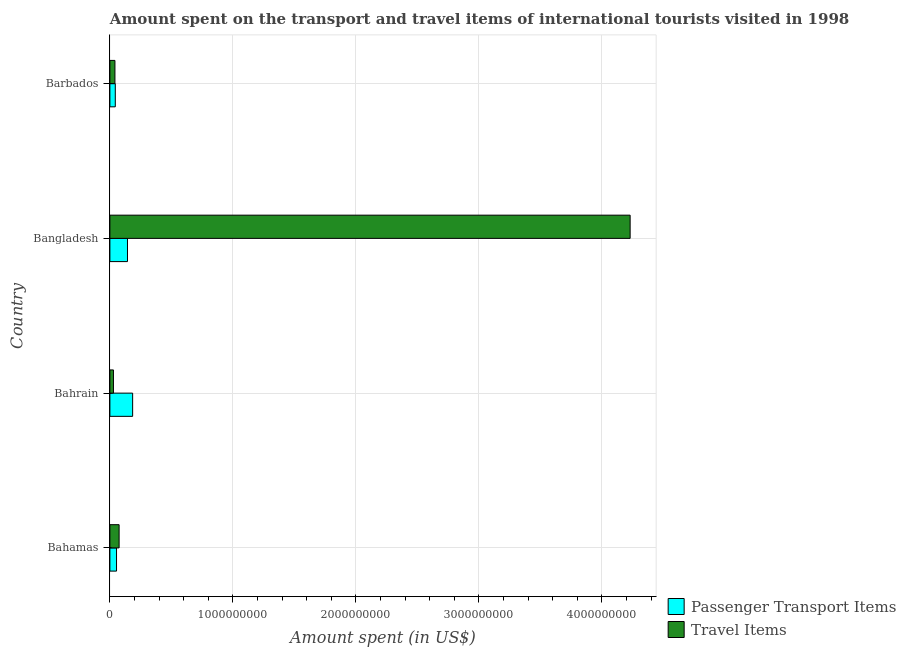Are the number of bars on each tick of the Y-axis equal?
Ensure brevity in your answer.  Yes. How many bars are there on the 1st tick from the top?
Your answer should be compact. 2. How many bars are there on the 1st tick from the bottom?
Ensure brevity in your answer.  2. What is the label of the 2nd group of bars from the top?
Provide a short and direct response. Bangladesh. In how many cases, is the number of bars for a given country not equal to the number of legend labels?
Make the answer very short. 0. What is the amount spent in travel items in Bangladesh?
Give a very brief answer. 4.23e+09. Across all countries, what is the maximum amount spent in travel items?
Make the answer very short. 4.23e+09. Across all countries, what is the minimum amount spent in travel items?
Provide a succinct answer. 2.90e+07. In which country was the amount spent on passenger transport items maximum?
Make the answer very short. Bahrain. In which country was the amount spent in travel items minimum?
Make the answer very short. Bahrain. What is the total amount spent on passenger transport items in the graph?
Give a very brief answer. 4.26e+08. What is the difference between the amount spent in travel items in Bahamas and that in Bangladesh?
Provide a succinct answer. -4.16e+09. What is the difference between the amount spent on passenger transport items in Bahrain and the amount spent in travel items in Barbados?
Provide a short and direct response. 1.44e+08. What is the average amount spent on passenger transport items per country?
Provide a succinct answer. 1.06e+08. What is the difference between the amount spent on passenger transport items and amount spent in travel items in Bahrain?
Offer a very short reply. 1.56e+08. What is the ratio of the amount spent on passenger transport items in Bahrain to that in Barbados?
Provide a short and direct response. 4.21. Is the difference between the amount spent in travel items in Bahrain and Barbados greater than the difference between the amount spent on passenger transport items in Bahrain and Barbados?
Ensure brevity in your answer.  No. What is the difference between the highest and the second highest amount spent in travel items?
Your response must be concise. 4.16e+09. What is the difference between the highest and the lowest amount spent in travel items?
Make the answer very short. 4.20e+09. What does the 2nd bar from the top in Bangladesh represents?
Your answer should be very brief. Passenger Transport Items. What does the 1st bar from the bottom in Bahamas represents?
Give a very brief answer. Passenger Transport Items. How many bars are there?
Provide a succinct answer. 8. How many countries are there in the graph?
Ensure brevity in your answer.  4. What is the difference between two consecutive major ticks on the X-axis?
Keep it short and to the point. 1.00e+09. Are the values on the major ticks of X-axis written in scientific E-notation?
Your answer should be very brief. No. Does the graph contain grids?
Give a very brief answer. Yes. How many legend labels are there?
Offer a very short reply. 2. How are the legend labels stacked?
Provide a short and direct response. Vertical. What is the title of the graph?
Give a very brief answer. Amount spent on the transport and travel items of international tourists visited in 1998. What is the label or title of the X-axis?
Your answer should be very brief. Amount spent (in US$). What is the label or title of the Y-axis?
Your answer should be very brief. Country. What is the Amount spent (in US$) of Passenger Transport Items in Bahamas?
Keep it short and to the point. 5.40e+07. What is the Amount spent (in US$) of Travel Items in Bahamas?
Provide a succinct answer. 7.50e+07. What is the Amount spent (in US$) of Passenger Transport Items in Bahrain?
Your response must be concise. 1.85e+08. What is the Amount spent (in US$) of Travel Items in Bahrain?
Your answer should be very brief. 2.90e+07. What is the Amount spent (in US$) of Passenger Transport Items in Bangladesh?
Provide a short and direct response. 1.43e+08. What is the Amount spent (in US$) in Travel Items in Bangladesh?
Offer a terse response. 4.23e+09. What is the Amount spent (in US$) in Passenger Transport Items in Barbados?
Make the answer very short. 4.40e+07. What is the Amount spent (in US$) of Travel Items in Barbados?
Offer a terse response. 4.10e+07. Across all countries, what is the maximum Amount spent (in US$) in Passenger Transport Items?
Give a very brief answer. 1.85e+08. Across all countries, what is the maximum Amount spent (in US$) in Travel Items?
Offer a very short reply. 4.23e+09. Across all countries, what is the minimum Amount spent (in US$) of Passenger Transport Items?
Offer a terse response. 4.40e+07. Across all countries, what is the minimum Amount spent (in US$) of Travel Items?
Your response must be concise. 2.90e+07. What is the total Amount spent (in US$) of Passenger Transport Items in the graph?
Provide a short and direct response. 4.26e+08. What is the total Amount spent (in US$) of Travel Items in the graph?
Keep it short and to the point. 4.38e+09. What is the difference between the Amount spent (in US$) in Passenger Transport Items in Bahamas and that in Bahrain?
Provide a short and direct response. -1.31e+08. What is the difference between the Amount spent (in US$) of Travel Items in Bahamas and that in Bahrain?
Your answer should be very brief. 4.60e+07. What is the difference between the Amount spent (in US$) in Passenger Transport Items in Bahamas and that in Bangladesh?
Your response must be concise. -8.90e+07. What is the difference between the Amount spent (in US$) in Travel Items in Bahamas and that in Bangladesh?
Give a very brief answer. -4.16e+09. What is the difference between the Amount spent (in US$) of Travel Items in Bahamas and that in Barbados?
Your answer should be compact. 3.40e+07. What is the difference between the Amount spent (in US$) of Passenger Transport Items in Bahrain and that in Bangladesh?
Give a very brief answer. 4.20e+07. What is the difference between the Amount spent (in US$) of Travel Items in Bahrain and that in Bangladesh?
Provide a succinct answer. -4.20e+09. What is the difference between the Amount spent (in US$) of Passenger Transport Items in Bahrain and that in Barbados?
Provide a succinct answer. 1.41e+08. What is the difference between the Amount spent (in US$) in Travel Items in Bahrain and that in Barbados?
Give a very brief answer. -1.20e+07. What is the difference between the Amount spent (in US$) of Passenger Transport Items in Bangladesh and that in Barbados?
Provide a succinct answer. 9.90e+07. What is the difference between the Amount spent (in US$) in Travel Items in Bangladesh and that in Barbados?
Keep it short and to the point. 4.19e+09. What is the difference between the Amount spent (in US$) of Passenger Transport Items in Bahamas and the Amount spent (in US$) of Travel Items in Bahrain?
Provide a succinct answer. 2.50e+07. What is the difference between the Amount spent (in US$) of Passenger Transport Items in Bahamas and the Amount spent (in US$) of Travel Items in Bangladesh?
Your answer should be compact. -4.18e+09. What is the difference between the Amount spent (in US$) in Passenger Transport Items in Bahamas and the Amount spent (in US$) in Travel Items in Barbados?
Give a very brief answer. 1.30e+07. What is the difference between the Amount spent (in US$) of Passenger Transport Items in Bahrain and the Amount spent (in US$) of Travel Items in Bangladesh?
Ensure brevity in your answer.  -4.04e+09. What is the difference between the Amount spent (in US$) of Passenger Transport Items in Bahrain and the Amount spent (in US$) of Travel Items in Barbados?
Your response must be concise. 1.44e+08. What is the difference between the Amount spent (in US$) in Passenger Transport Items in Bangladesh and the Amount spent (in US$) in Travel Items in Barbados?
Offer a terse response. 1.02e+08. What is the average Amount spent (in US$) of Passenger Transport Items per country?
Ensure brevity in your answer.  1.06e+08. What is the average Amount spent (in US$) of Travel Items per country?
Make the answer very short. 1.09e+09. What is the difference between the Amount spent (in US$) of Passenger Transport Items and Amount spent (in US$) of Travel Items in Bahamas?
Ensure brevity in your answer.  -2.10e+07. What is the difference between the Amount spent (in US$) in Passenger Transport Items and Amount spent (in US$) in Travel Items in Bahrain?
Your answer should be compact. 1.56e+08. What is the difference between the Amount spent (in US$) in Passenger Transport Items and Amount spent (in US$) in Travel Items in Bangladesh?
Provide a short and direct response. -4.09e+09. What is the ratio of the Amount spent (in US$) in Passenger Transport Items in Bahamas to that in Bahrain?
Provide a succinct answer. 0.29. What is the ratio of the Amount spent (in US$) of Travel Items in Bahamas to that in Bahrain?
Offer a terse response. 2.59. What is the ratio of the Amount spent (in US$) in Passenger Transport Items in Bahamas to that in Bangladesh?
Give a very brief answer. 0.38. What is the ratio of the Amount spent (in US$) in Travel Items in Bahamas to that in Bangladesh?
Your answer should be compact. 0.02. What is the ratio of the Amount spent (in US$) of Passenger Transport Items in Bahamas to that in Barbados?
Keep it short and to the point. 1.23. What is the ratio of the Amount spent (in US$) of Travel Items in Bahamas to that in Barbados?
Keep it short and to the point. 1.83. What is the ratio of the Amount spent (in US$) of Passenger Transport Items in Bahrain to that in Bangladesh?
Your answer should be compact. 1.29. What is the ratio of the Amount spent (in US$) of Travel Items in Bahrain to that in Bangladesh?
Offer a terse response. 0.01. What is the ratio of the Amount spent (in US$) in Passenger Transport Items in Bahrain to that in Barbados?
Your response must be concise. 4.2. What is the ratio of the Amount spent (in US$) of Travel Items in Bahrain to that in Barbados?
Provide a short and direct response. 0.71. What is the ratio of the Amount spent (in US$) of Passenger Transport Items in Bangladesh to that in Barbados?
Your answer should be compact. 3.25. What is the ratio of the Amount spent (in US$) of Travel Items in Bangladesh to that in Barbados?
Provide a succinct answer. 103.17. What is the difference between the highest and the second highest Amount spent (in US$) in Passenger Transport Items?
Offer a terse response. 4.20e+07. What is the difference between the highest and the second highest Amount spent (in US$) of Travel Items?
Keep it short and to the point. 4.16e+09. What is the difference between the highest and the lowest Amount spent (in US$) of Passenger Transport Items?
Keep it short and to the point. 1.41e+08. What is the difference between the highest and the lowest Amount spent (in US$) of Travel Items?
Provide a succinct answer. 4.20e+09. 